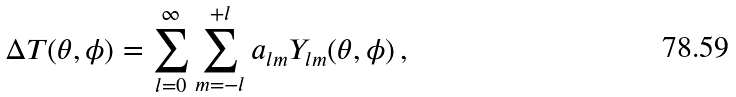Convert formula to latex. <formula><loc_0><loc_0><loc_500><loc_500>\Delta T ( \theta , \phi ) = \sum _ { l = 0 } ^ { \infty } \sum _ { m = - l } ^ { + l } a _ { l m } Y _ { l m } ( \theta , \phi ) \, ,</formula> 